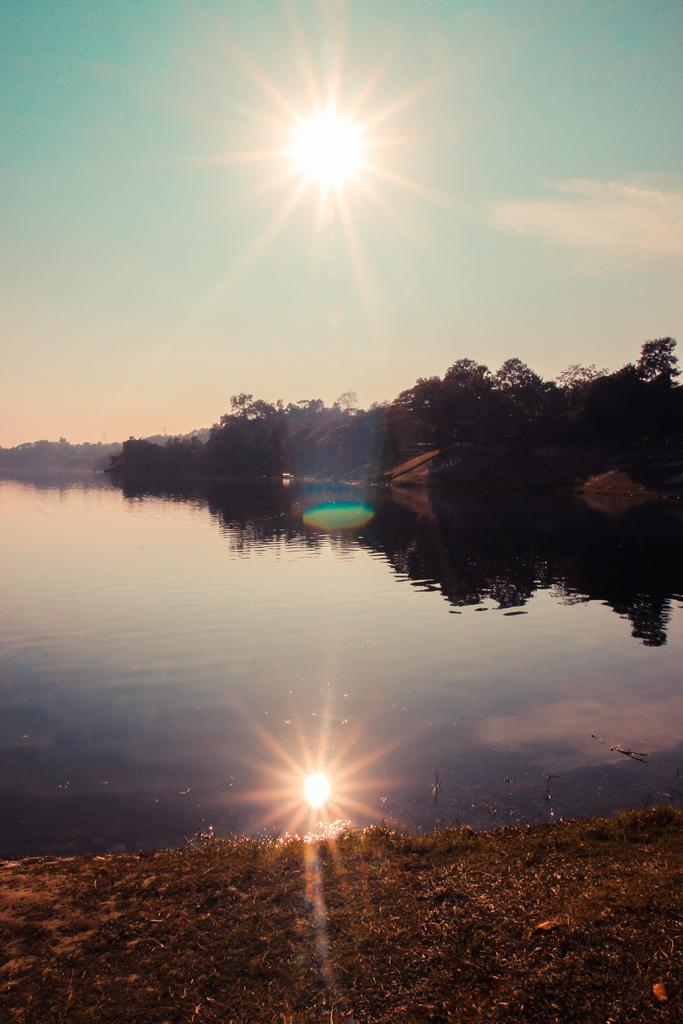What is the primary element visible in the image? There is water in the image. What type of vegetation is near the water? There are trees beside the water. What can be seen in the sky at the top of the image? The sun is visible in the sky at the top of the image. What type of stove is being used by the minister in the image? There is no stove or minister present in the image. 